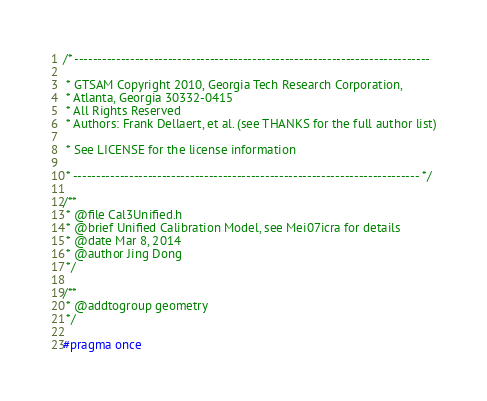Convert code to text. <code><loc_0><loc_0><loc_500><loc_500><_C_>/* ----------------------------------------------------------------------------

 * GTSAM Copyright 2010, Georgia Tech Research Corporation,
 * Atlanta, Georgia 30332-0415
 * All Rights Reserved
 * Authors: Frank Dellaert, et al. (see THANKS for the full author list)

 * See LICENSE for the license information

 * -------------------------------------------------------------------------- */

/**
 * @file Cal3Unified.h
 * @brief Unified Calibration Model, see Mei07icra for details
 * @date Mar 8, 2014
 * @author Jing Dong
 */

/**
 * @addtogroup geometry
 */

#pragma once
</code> 